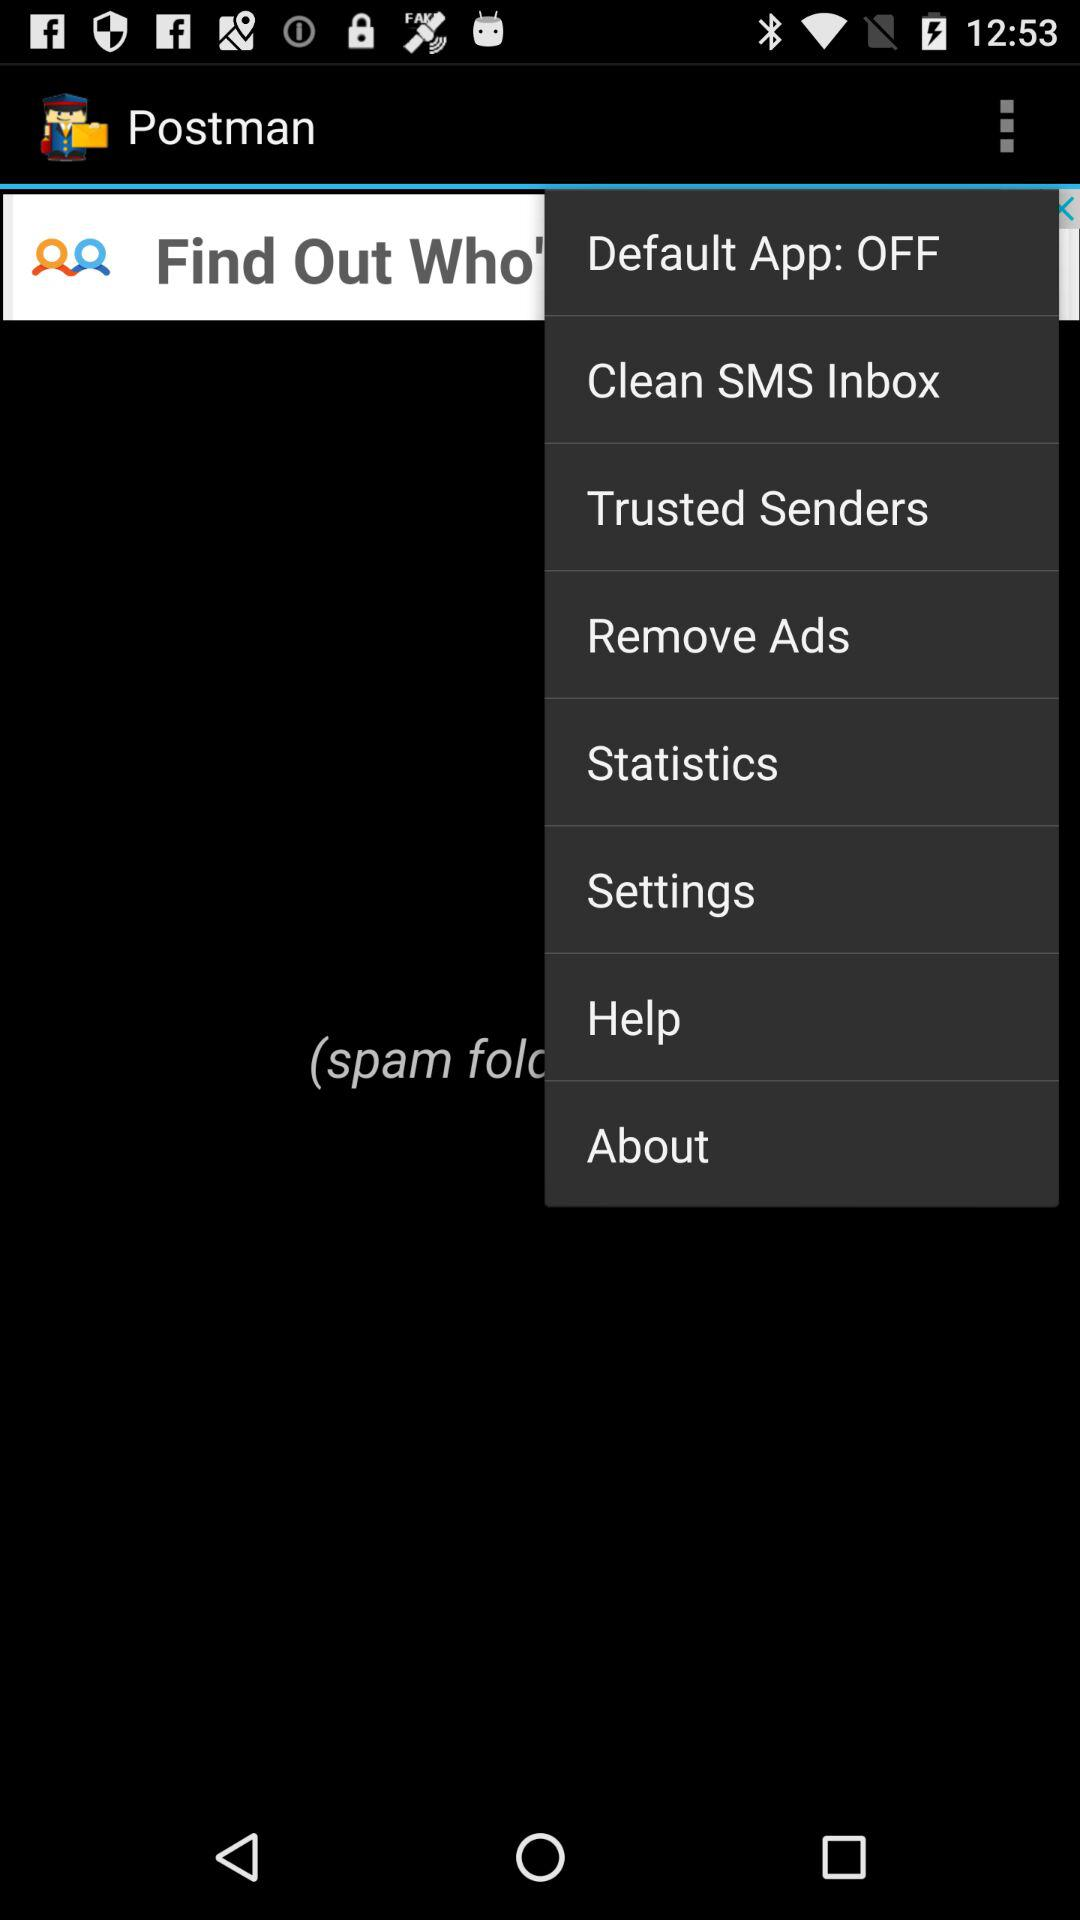What is the status of "Default App"? The status is "off". 